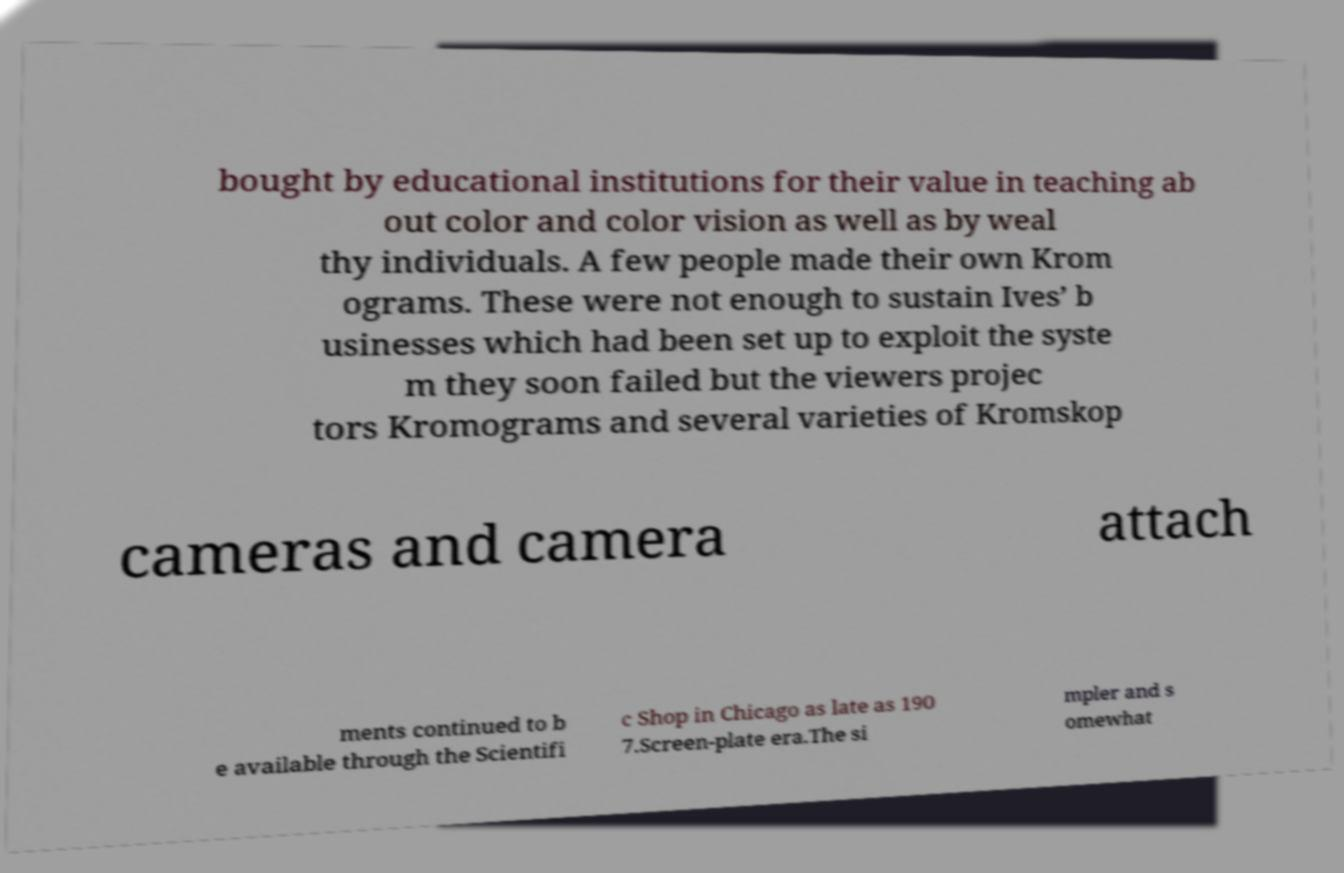Please identify and transcribe the text found in this image. bought by educational institutions for their value in teaching ab out color and color vision as well as by weal thy individuals. A few people made their own Krom ograms. These were not enough to sustain Ives’ b usinesses which had been set up to exploit the syste m they soon failed but the viewers projec tors Kromograms and several varieties of Kromskop cameras and camera attach ments continued to b e available through the Scientifi c Shop in Chicago as late as 190 7.Screen-plate era.The si mpler and s omewhat 